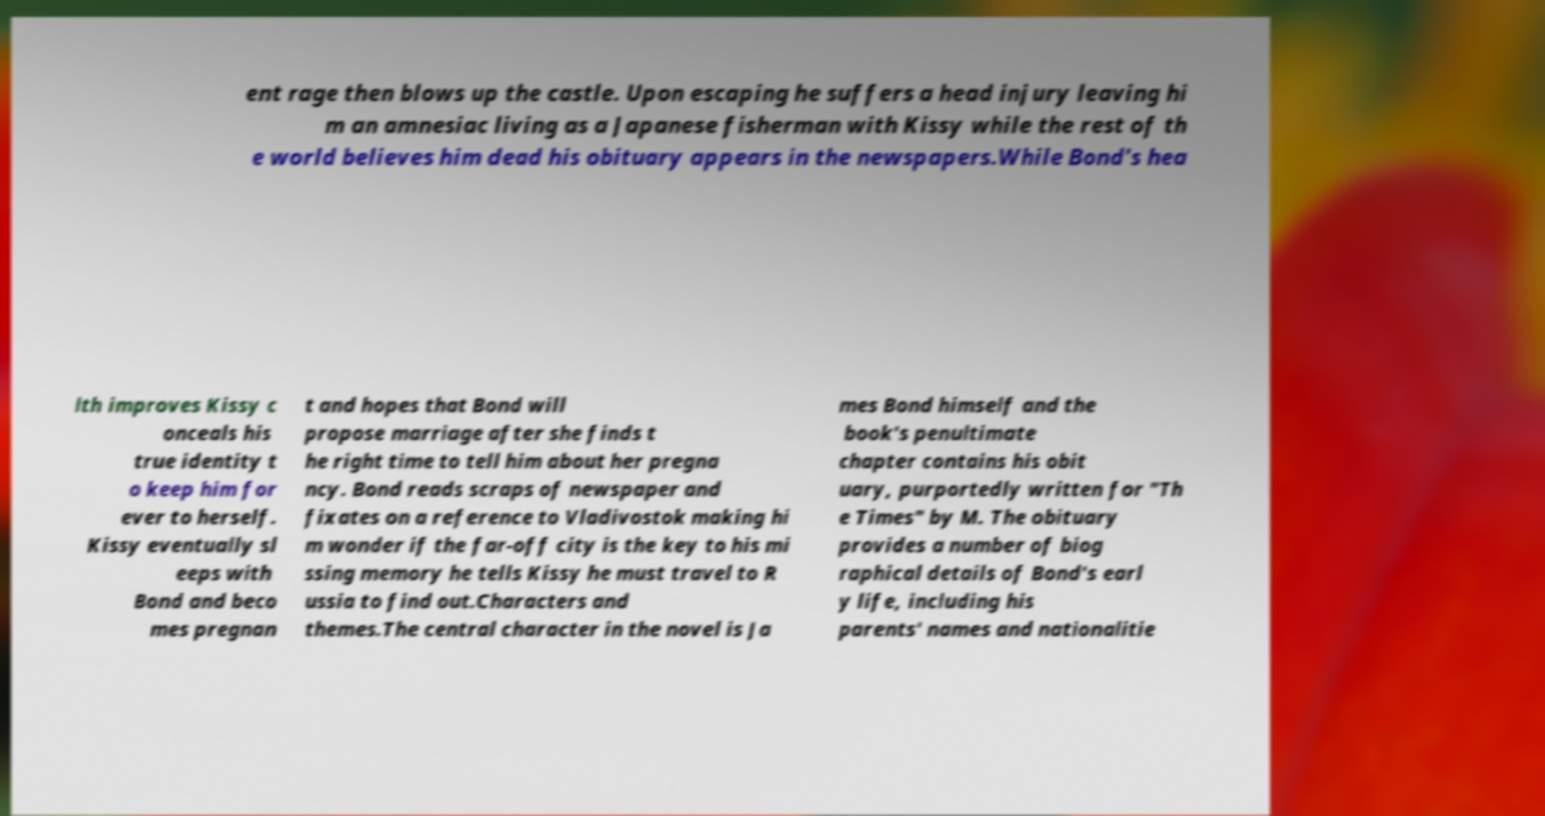There's text embedded in this image that I need extracted. Can you transcribe it verbatim? ent rage then blows up the castle. Upon escaping he suffers a head injury leaving hi m an amnesiac living as a Japanese fisherman with Kissy while the rest of th e world believes him dead his obituary appears in the newspapers.While Bond's hea lth improves Kissy c onceals his true identity t o keep him for ever to herself. Kissy eventually sl eeps with Bond and beco mes pregnan t and hopes that Bond will propose marriage after she finds t he right time to tell him about her pregna ncy. Bond reads scraps of newspaper and fixates on a reference to Vladivostok making hi m wonder if the far-off city is the key to his mi ssing memory he tells Kissy he must travel to R ussia to find out.Characters and themes.The central character in the novel is Ja mes Bond himself and the book's penultimate chapter contains his obit uary, purportedly written for "Th e Times" by M. The obituary provides a number of biog raphical details of Bond's earl y life, including his parents' names and nationalitie 